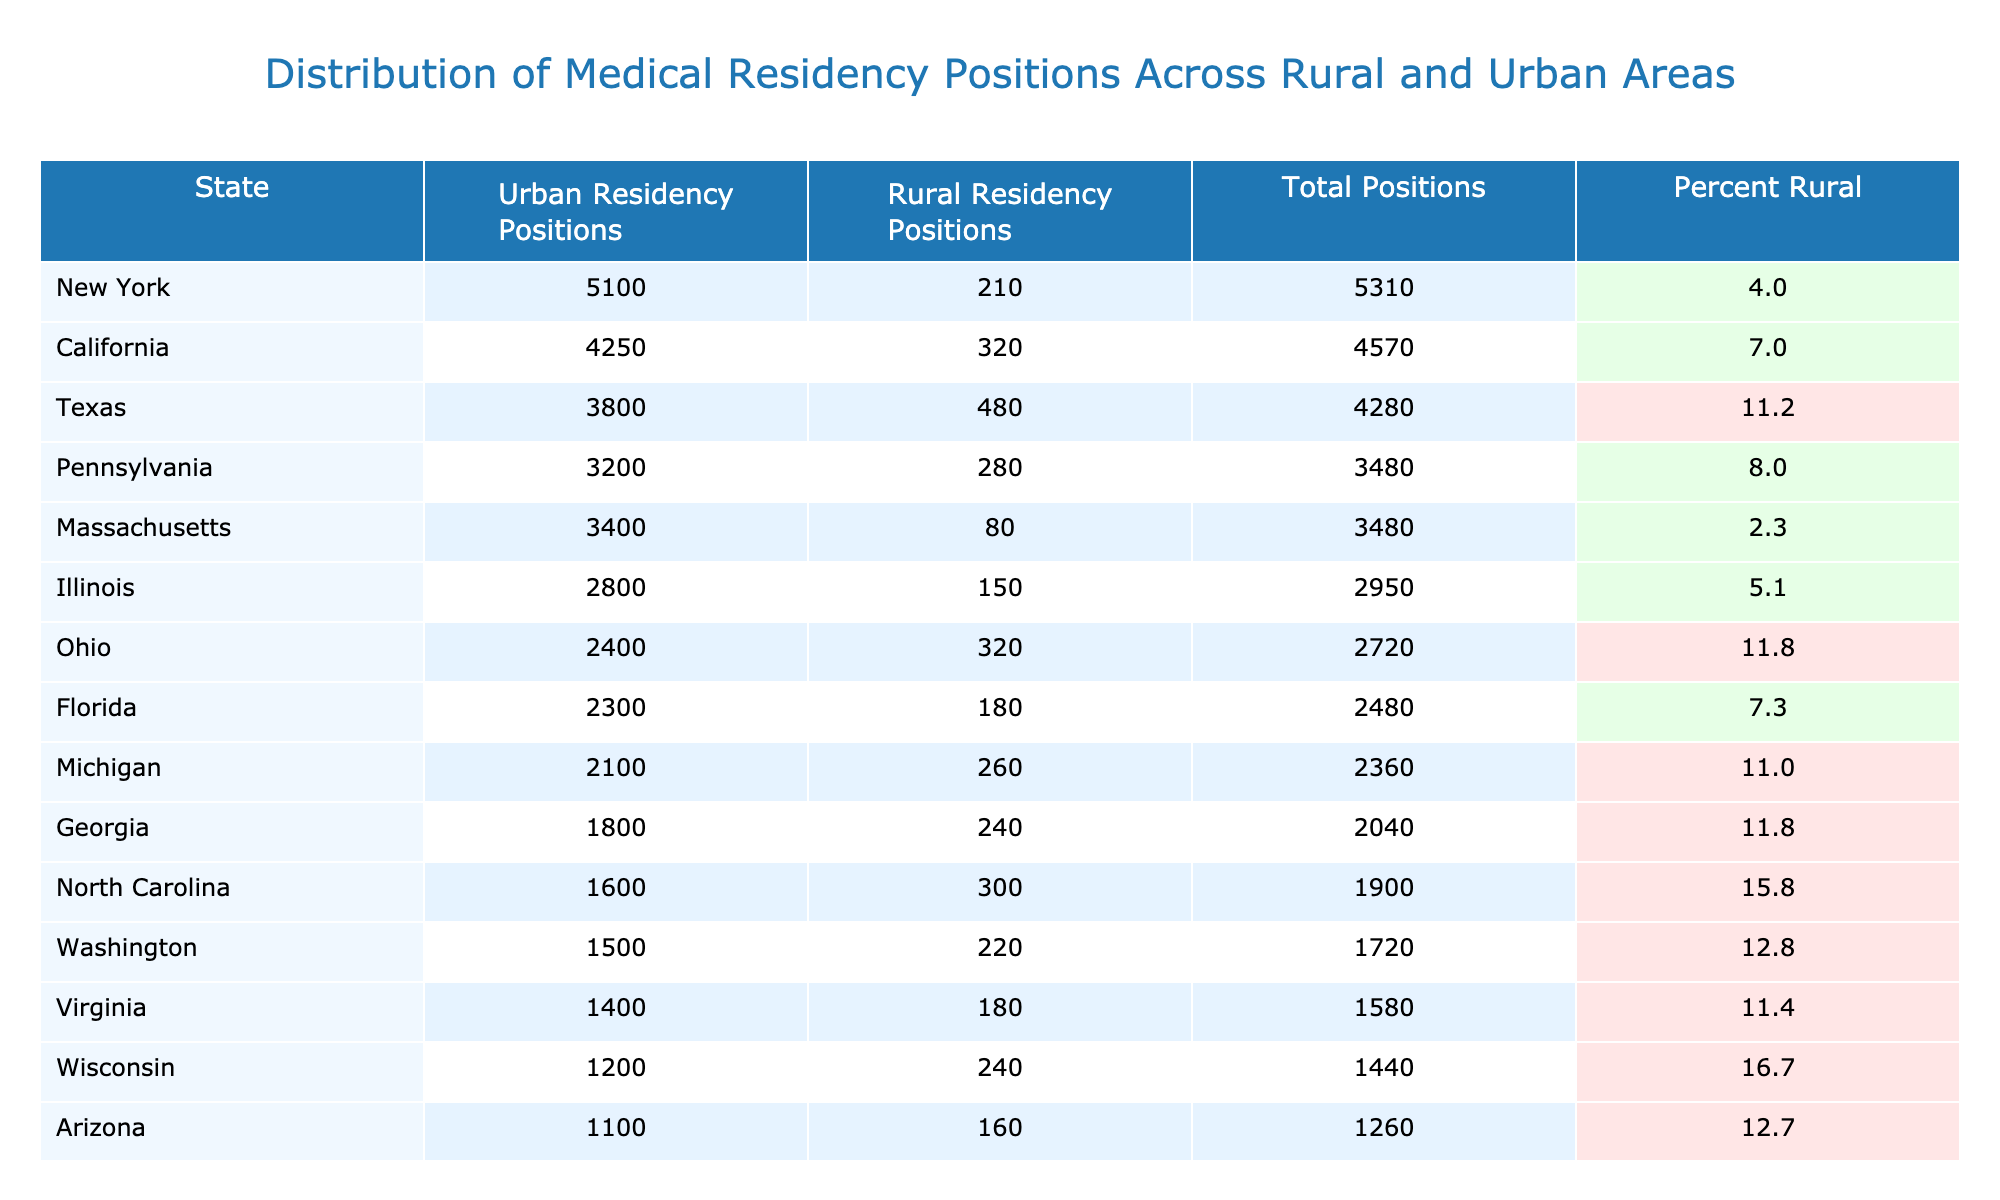What state has the highest number of urban residency positions? By looking at the "Urban Residency Positions" column, California has the highest count with 4250 positions.
Answer: California Which state has the least number of rural residency positions? Examining the "Rural Residency Positions" column, Massachusetts has just 80 rural residency positions, which is the lowest.
Answer: Massachusetts What is the total number of residency positions in Texas? The total number of residency positions for Texas is listed in the "Total Positions" column, which shows 4280 positions.
Answer: 4280 What percentage of residency positions are rural in North Carolina? The "Percent Rural" column indicates that North Carolina has 15.8% of its residency positions in rural areas.
Answer: 15.8% What is the difference in urban residency positions between California and Florida? California has 4250 urban positions and Florida has 2300; subtracting these gives 4250 - 2300 = 1950.
Answer: 1950 Is the percentage of rural residency positions in Georgia greater than in Ohio? Looking at the "Percent Rural" column, Georgia has 11.8% and Ohio also has 11.8%. Hence, they are equal, so the answer is no.
Answer: No What is the average total number of residency positions across all states in the table? The total positions can be summed up (4570 + 4280 + 5310 + 2480 + 2950 + 3480 + 2720 + 2040 + 2360 + 1900 + 3480 + 1720 + 1580 + 1260 + 1440) = 49710. There are 15 states, so dividing gives 49710 / 15 = 3314.
Answer: 3314 How many states have more than 10% of their residency positions in rural areas? By checking the "Percent Rural" column, I find that Texas, Ohio, Georgia, North Carolina, Washington, Virginia, Arizona, and Wisconsin are the states with values greater than 10%, totaling 8 states.
Answer: 8 Which state has the highest percentage of rural residency positions? Reviewing the table, Wisconsin shows the highest percentage of rural residency positions at 16.7%.
Answer: Wisconsin Are there more urban residency positions in New York or Illinois? Comparing the "Urban Residency Positions", New York has 5100 and Illinois has 2800, indicating that New York has more urban residency positions.
Answer: New York 